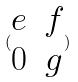<formula> <loc_0><loc_0><loc_500><loc_500>( \begin{matrix} e & f \\ 0 & g \end{matrix} )</formula> 